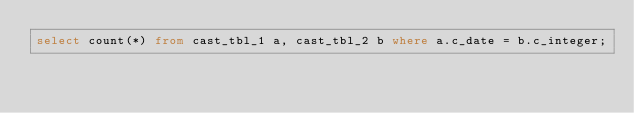<code> <loc_0><loc_0><loc_500><loc_500><_SQL_>select count(*) from cast_tbl_1 a, cast_tbl_2 b where a.c_date = b.c_integer;
</code> 